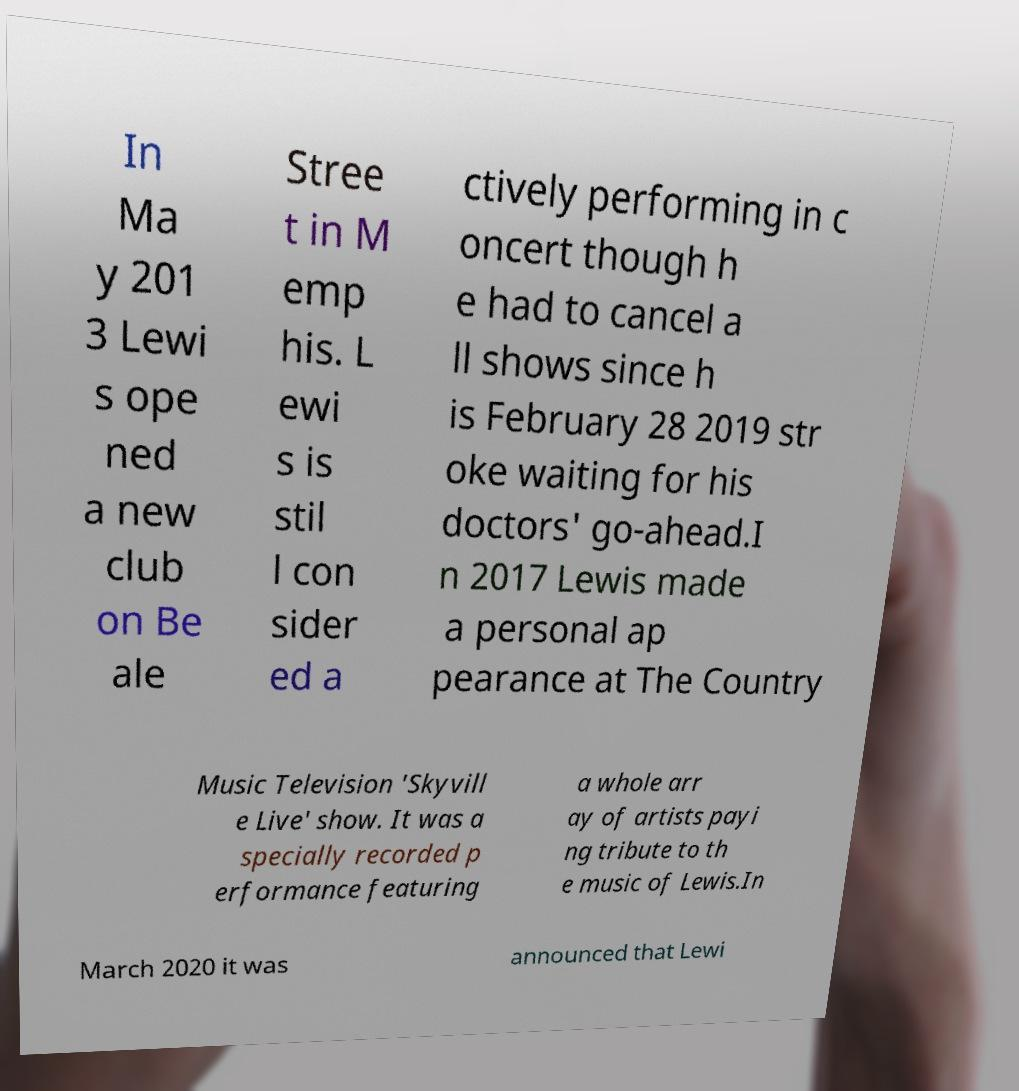Can you read and provide the text displayed in the image?This photo seems to have some interesting text. Can you extract and type it out for me? In Ma y 201 3 Lewi s ope ned a new club on Be ale Stree t in M emp his. L ewi s is stil l con sider ed a ctively performing in c oncert though h e had to cancel a ll shows since h is February 28 2019 str oke waiting for his doctors' go-ahead.I n 2017 Lewis made a personal ap pearance at The Country Music Television 'Skyvill e Live' show. It was a specially recorded p erformance featuring a whole arr ay of artists payi ng tribute to th e music of Lewis.In March 2020 it was announced that Lewi 